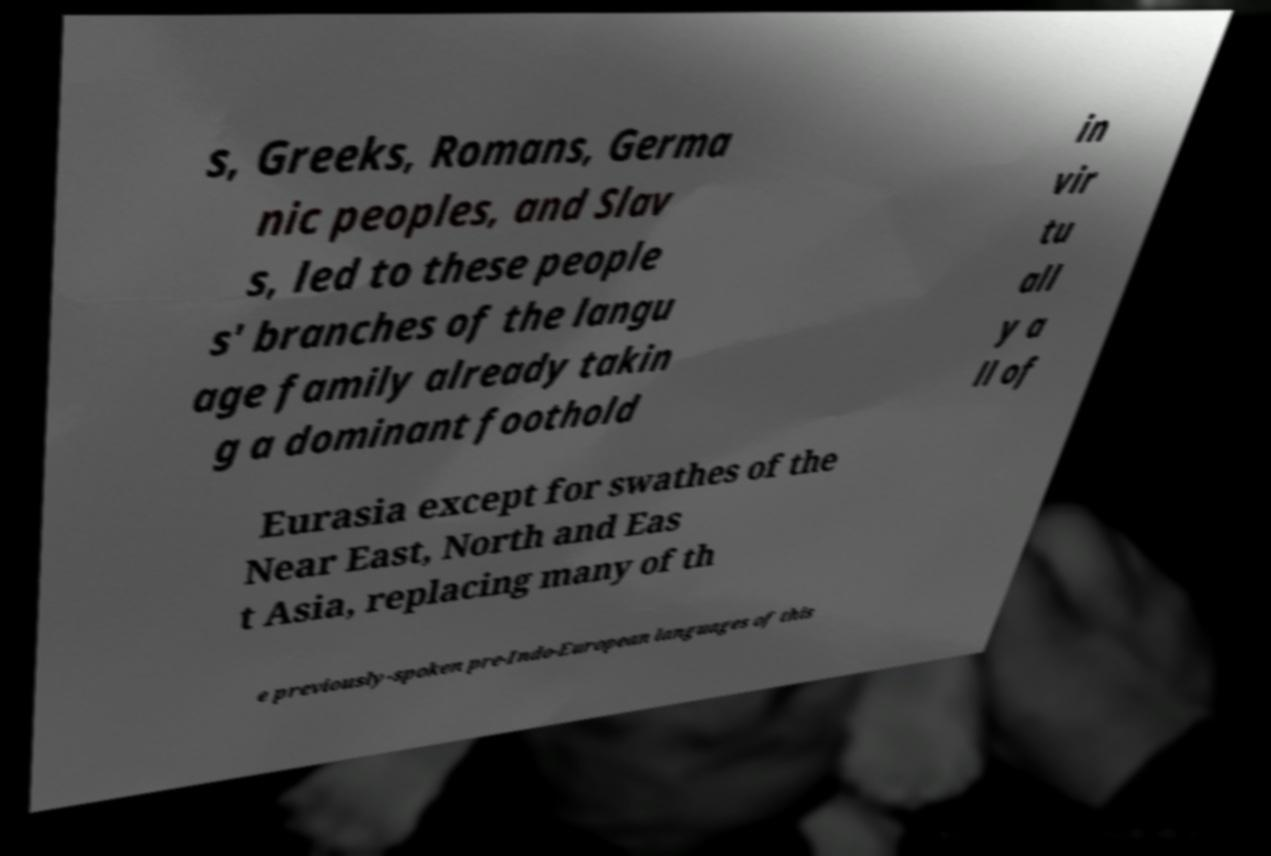For documentation purposes, I need the text within this image transcribed. Could you provide that? s, Greeks, Romans, Germa nic peoples, and Slav s, led to these people s' branches of the langu age family already takin g a dominant foothold in vir tu all y a ll of Eurasia except for swathes of the Near East, North and Eas t Asia, replacing many of th e previously-spoken pre-Indo-European languages of this 